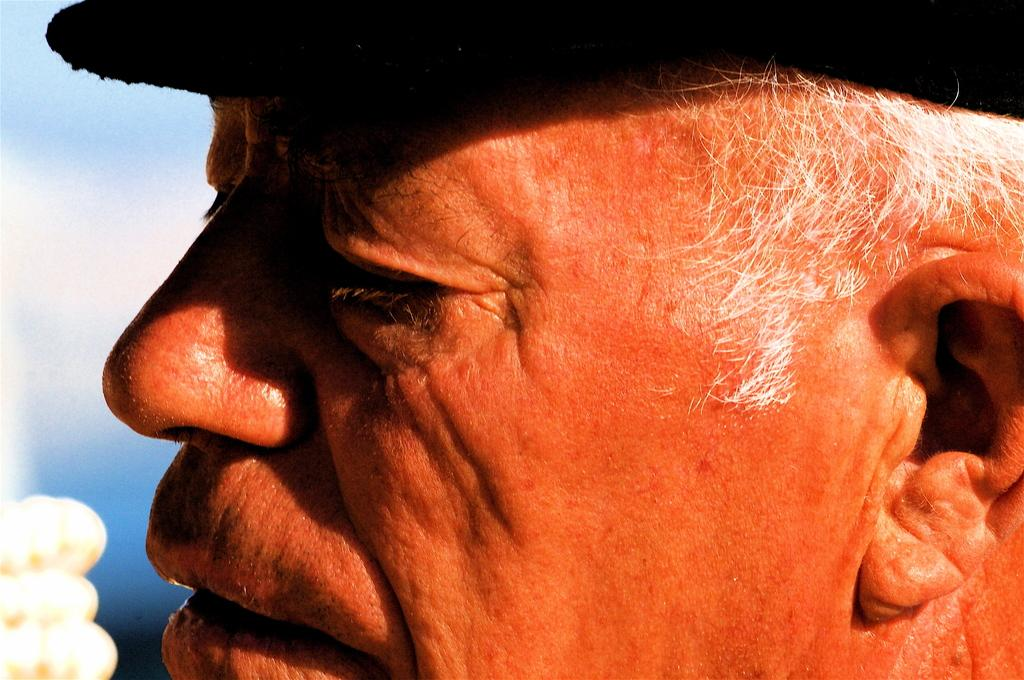Who is the main subject in the image? There is an old man in the image. Where is the old man located in the image? The old man is in the center of the image. What type of art can be seen on the old man's shoes in the image? There is no art visible on the old man's shoes in the image, as the facts provided do not mention any shoes or art. 